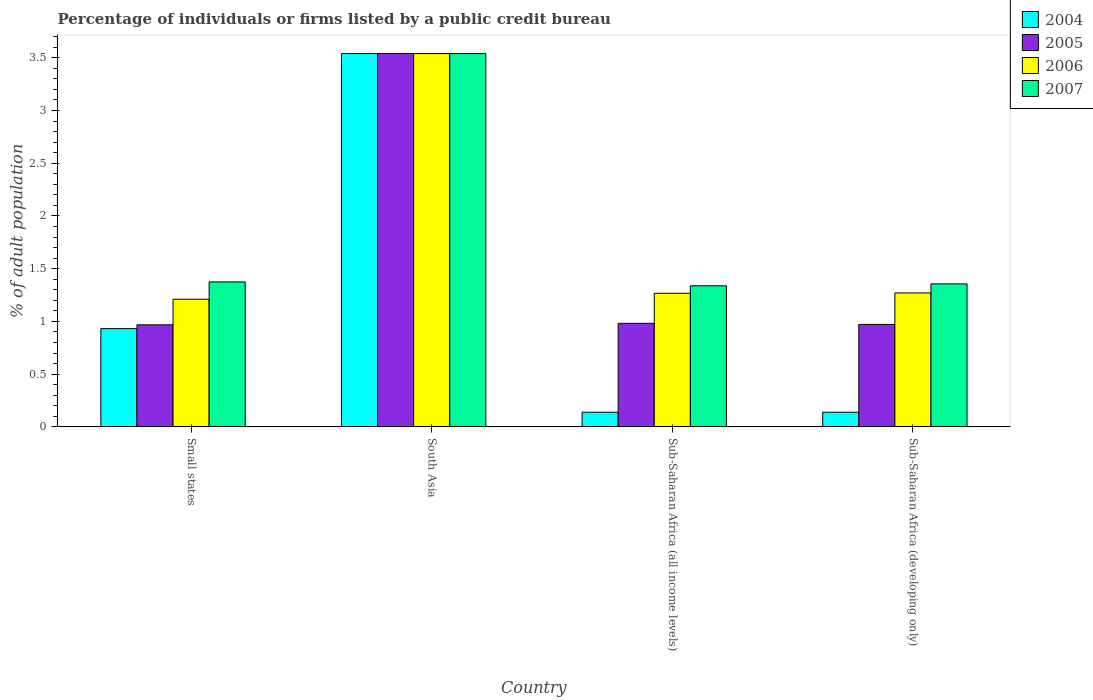How many different coloured bars are there?
Offer a very short reply. 4. How many groups of bars are there?
Provide a short and direct response. 4. Are the number of bars per tick equal to the number of legend labels?
Provide a succinct answer. Yes. How many bars are there on the 3rd tick from the left?
Provide a succinct answer. 4. What is the label of the 3rd group of bars from the left?
Provide a succinct answer. Sub-Saharan Africa (all income levels). What is the percentage of population listed by a public credit bureau in 2006 in Sub-Saharan Africa (developing only)?
Give a very brief answer. 1.27. Across all countries, what is the maximum percentage of population listed by a public credit bureau in 2005?
Your answer should be very brief. 3.54. Across all countries, what is the minimum percentage of population listed by a public credit bureau in 2004?
Ensure brevity in your answer.  0.14. In which country was the percentage of population listed by a public credit bureau in 2006 maximum?
Keep it short and to the point. South Asia. In which country was the percentage of population listed by a public credit bureau in 2006 minimum?
Offer a very short reply. Small states. What is the total percentage of population listed by a public credit bureau in 2006 in the graph?
Make the answer very short. 7.29. What is the difference between the percentage of population listed by a public credit bureau in 2005 in South Asia and that in Sub-Saharan Africa (developing only)?
Provide a succinct answer. 2.57. What is the difference between the percentage of population listed by a public credit bureau in 2006 in Small states and the percentage of population listed by a public credit bureau in 2007 in South Asia?
Keep it short and to the point. -2.33. What is the average percentage of population listed by a public credit bureau in 2005 per country?
Provide a succinct answer. 1.62. What is the difference between the percentage of population listed by a public credit bureau of/in 2004 and percentage of population listed by a public credit bureau of/in 2005 in Small states?
Give a very brief answer. -0.04. In how many countries, is the percentage of population listed by a public credit bureau in 2004 greater than 0.1 %?
Provide a succinct answer. 4. What is the ratio of the percentage of population listed by a public credit bureau in 2004 in Sub-Saharan Africa (all income levels) to that in Sub-Saharan Africa (developing only)?
Offer a very short reply. 1. Is the percentage of population listed by a public credit bureau in 2004 in Sub-Saharan Africa (all income levels) less than that in Sub-Saharan Africa (developing only)?
Provide a short and direct response. No. What is the difference between the highest and the second highest percentage of population listed by a public credit bureau in 2006?
Ensure brevity in your answer.  -2.27. What is the difference between the highest and the lowest percentage of population listed by a public credit bureau in 2005?
Give a very brief answer. 2.57. In how many countries, is the percentage of population listed by a public credit bureau in 2004 greater than the average percentage of population listed by a public credit bureau in 2004 taken over all countries?
Provide a short and direct response. 1. Is the sum of the percentage of population listed by a public credit bureau in 2005 in Small states and South Asia greater than the maximum percentage of population listed by a public credit bureau in 2006 across all countries?
Keep it short and to the point. Yes. Is it the case that in every country, the sum of the percentage of population listed by a public credit bureau in 2004 and percentage of population listed by a public credit bureau in 2006 is greater than the percentage of population listed by a public credit bureau in 2007?
Ensure brevity in your answer.  Yes. How many bars are there?
Provide a short and direct response. 16. What is the difference between two consecutive major ticks on the Y-axis?
Provide a short and direct response. 0.5. Are the values on the major ticks of Y-axis written in scientific E-notation?
Ensure brevity in your answer.  No. Does the graph contain any zero values?
Your answer should be very brief. No. How are the legend labels stacked?
Provide a succinct answer. Vertical. What is the title of the graph?
Offer a terse response. Percentage of individuals or firms listed by a public credit bureau. What is the label or title of the Y-axis?
Offer a very short reply. % of adult population. What is the % of adult population of 2004 in Small states?
Make the answer very short. 0.93. What is the % of adult population in 2005 in Small states?
Make the answer very short. 0.97. What is the % of adult population in 2006 in Small states?
Offer a terse response. 1.21. What is the % of adult population of 2007 in Small states?
Give a very brief answer. 1.37. What is the % of adult population of 2004 in South Asia?
Your response must be concise. 3.54. What is the % of adult population of 2005 in South Asia?
Provide a succinct answer. 3.54. What is the % of adult population of 2006 in South Asia?
Give a very brief answer. 3.54. What is the % of adult population of 2007 in South Asia?
Offer a very short reply. 3.54. What is the % of adult population in 2004 in Sub-Saharan Africa (all income levels)?
Give a very brief answer. 0.14. What is the % of adult population of 2005 in Sub-Saharan Africa (all income levels)?
Ensure brevity in your answer.  0.98. What is the % of adult population in 2006 in Sub-Saharan Africa (all income levels)?
Ensure brevity in your answer.  1.27. What is the % of adult population in 2007 in Sub-Saharan Africa (all income levels)?
Provide a short and direct response. 1.34. What is the % of adult population in 2004 in Sub-Saharan Africa (developing only)?
Provide a short and direct response. 0.14. What is the % of adult population in 2005 in Sub-Saharan Africa (developing only)?
Ensure brevity in your answer.  0.97. What is the % of adult population of 2006 in Sub-Saharan Africa (developing only)?
Keep it short and to the point. 1.27. What is the % of adult population in 2007 in Sub-Saharan Africa (developing only)?
Offer a terse response. 1.36. Across all countries, what is the maximum % of adult population in 2004?
Your answer should be compact. 3.54. Across all countries, what is the maximum % of adult population in 2005?
Ensure brevity in your answer.  3.54. Across all countries, what is the maximum % of adult population in 2006?
Make the answer very short. 3.54. Across all countries, what is the maximum % of adult population of 2007?
Give a very brief answer. 3.54. Across all countries, what is the minimum % of adult population in 2004?
Provide a short and direct response. 0.14. Across all countries, what is the minimum % of adult population in 2005?
Offer a terse response. 0.97. Across all countries, what is the minimum % of adult population in 2006?
Provide a short and direct response. 1.21. Across all countries, what is the minimum % of adult population of 2007?
Provide a short and direct response. 1.34. What is the total % of adult population in 2004 in the graph?
Offer a terse response. 4.75. What is the total % of adult population in 2005 in the graph?
Your response must be concise. 6.46. What is the total % of adult population of 2006 in the graph?
Offer a very short reply. 7.29. What is the total % of adult population of 2007 in the graph?
Offer a terse response. 7.61. What is the difference between the % of adult population of 2004 in Small states and that in South Asia?
Your response must be concise. -2.61. What is the difference between the % of adult population of 2005 in Small states and that in South Asia?
Offer a terse response. -2.57. What is the difference between the % of adult population in 2006 in Small states and that in South Asia?
Provide a short and direct response. -2.33. What is the difference between the % of adult population of 2007 in Small states and that in South Asia?
Offer a very short reply. -2.17. What is the difference between the % of adult population in 2004 in Small states and that in Sub-Saharan Africa (all income levels)?
Ensure brevity in your answer.  0.79. What is the difference between the % of adult population of 2005 in Small states and that in Sub-Saharan Africa (all income levels)?
Your answer should be compact. -0.01. What is the difference between the % of adult population in 2006 in Small states and that in Sub-Saharan Africa (all income levels)?
Your answer should be compact. -0.06. What is the difference between the % of adult population in 2007 in Small states and that in Sub-Saharan Africa (all income levels)?
Offer a very short reply. 0.04. What is the difference between the % of adult population in 2004 in Small states and that in Sub-Saharan Africa (developing only)?
Offer a very short reply. 0.79. What is the difference between the % of adult population of 2005 in Small states and that in Sub-Saharan Africa (developing only)?
Your answer should be very brief. -0. What is the difference between the % of adult population of 2006 in Small states and that in Sub-Saharan Africa (developing only)?
Provide a succinct answer. -0.06. What is the difference between the % of adult population of 2007 in Small states and that in Sub-Saharan Africa (developing only)?
Provide a succinct answer. 0.02. What is the difference between the % of adult population in 2004 in South Asia and that in Sub-Saharan Africa (all income levels)?
Ensure brevity in your answer.  3.4. What is the difference between the % of adult population of 2005 in South Asia and that in Sub-Saharan Africa (all income levels)?
Your answer should be compact. 2.56. What is the difference between the % of adult population in 2006 in South Asia and that in Sub-Saharan Africa (all income levels)?
Offer a very short reply. 2.27. What is the difference between the % of adult population of 2007 in South Asia and that in Sub-Saharan Africa (all income levels)?
Your answer should be very brief. 2.2. What is the difference between the % of adult population of 2004 in South Asia and that in Sub-Saharan Africa (developing only)?
Your answer should be compact. 3.4. What is the difference between the % of adult population of 2005 in South Asia and that in Sub-Saharan Africa (developing only)?
Your answer should be compact. 2.57. What is the difference between the % of adult population of 2006 in South Asia and that in Sub-Saharan Africa (developing only)?
Provide a succinct answer. 2.27. What is the difference between the % of adult population of 2007 in South Asia and that in Sub-Saharan Africa (developing only)?
Keep it short and to the point. 2.18. What is the difference between the % of adult population of 2005 in Sub-Saharan Africa (all income levels) and that in Sub-Saharan Africa (developing only)?
Offer a terse response. 0.01. What is the difference between the % of adult population of 2006 in Sub-Saharan Africa (all income levels) and that in Sub-Saharan Africa (developing only)?
Your answer should be very brief. -0. What is the difference between the % of adult population in 2007 in Sub-Saharan Africa (all income levels) and that in Sub-Saharan Africa (developing only)?
Your answer should be compact. -0.02. What is the difference between the % of adult population of 2004 in Small states and the % of adult population of 2005 in South Asia?
Your answer should be compact. -2.61. What is the difference between the % of adult population in 2004 in Small states and the % of adult population in 2006 in South Asia?
Keep it short and to the point. -2.61. What is the difference between the % of adult population in 2004 in Small states and the % of adult population in 2007 in South Asia?
Offer a very short reply. -2.61. What is the difference between the % of adult population in 2005 in Small states and the % of adult population in 2006 in South Asia?
Offer a terse response. -2.57. What is the difference between the % of adult population of 2005 in Small states and the % of adult population of 2007 in South Asia?
Give a very brief answer. -2.57. What is the difference between the % of adult population of 2006 in Small states and the % of adult population of 2007 in South Asia?
Offer a terse response. -2.33. What is the difference between the % of adult population in 2004 in Small states and the % of adult population in 2005 in Sub-Saharan Africa (all income levels)?
Offer a very short reply. -0.05. What is the difference between the % of adult population of 2004 in Small states and the % of adult population of 2006 in Sub-Saharan Africa (all income levels)?
Make the answer very short. -0.34. What is the difference between the % of adult population in 2004 in Small states and the % of adult population in 2007 in Sub-Saharan Africa (all income levels)?
Your answer should be compact. -0.41. What is the difference between the % of adult population of 2005 in Small states and the % of adult population of 2006 in Sub-Saharan Africa (all income levels)?
Your response must be concise. -0.3. What is the difference between the % of adult population in 2005 in Small states and the % of adult population in 2007 in Sub-Saharan Africa (all income levels)?
Make the answer very short. -0.37. What is the difference between the % of adult population in 2006 in Small states and the % of adult population in 2007 in Sub-Saharan Africa (all income levels)?
Provide a succinct answer. -0.13. What is the difference between the % of adult population of 2004 in Small states and the % of adult population of 2005 in Sub-Saharan Africa (developing only)?
Offer a terse response. -0.04. What is the difference between the % of adult population in 2004 in Small states and the % of adult population in 2006 in Sub-Saharan Africa (developing only)?
Your response must be concise. -0.34. What is the difference between the % of adult population in 2004 in Small states and the % of adult population in 2007 in Sub-Saharan Africa (developing only)?
Give a very brief answer. -0.42. What is the difference between the % of adult population of 2005 in Small states and the % of adult population of 2006 in Sub-Saharan Africa (developing only)?
Keep it short and to the point. -0.3. What is the difference between the % of adult population of 2005 in Small states and the % of adult population of 2007 in Sub-Saharan Africa (developing only)?
Your response must be concise. -0.39. What is the difference between the % of adult population of 2006 in Small states and the % of adult population of 2007 in Sub-Saharan Africa (developing only)?
Give a very brief answer. -0.15. What is the difference between the % of adult population in 2004 in South Asia and the % of adult population in 2005 in Sub-Saharan Africa (all income levels)?
Provide a short and direct response. 2.56. What is the difference between the % of adult population in 2004 in South Asia and the % of adult population in 2006 in Sub-Saharan Africa (all income levels)?
Your response must be concise. 2.27. What is the difference between the % of adult population in 2004 in South Asia and the % of adult population in 2007 in Sub-Saharan Africa (all income levels)?
Offer a terse response. 2.2. What is the difference between the % of adult population of 2005 in South Asia and the % of adult population of 2006 in Sub-Saharan Africa (all income levels)?
Make the answer very short. 2.27. What is the difference between the % of adult population of 2005 in South Asia and the % of adult population of 2007 in Sub-Saharan Africa (all income levels)?
Keep it short and to the point. 2.2. What is the difference between the % of adult population in 2006 in South Asia and the % of adult population in 2007 in Sub-Saharan Africa (all income levels)?
Provide a short and direct response. 2.2. What is the difference between the % of adult population in 2004 in South Asia and the % of adult population in 2005 in Sub-Saharan Africa (developing only)?
Provide a short and direct response. 2.57. What is the difference between the % of adult population in 2004 in South Asia and the % of adult population in 2006 in Sub-Saharan Africa (developing only)?
Your answer should be very brief. 2.27. What is the difference between the % of adult population in 2004 in South Asia and the % of adult population in 2007 in Sub-Saharan Africa (developing only)?
Your response must be concise. 2.18. What is the difference between the % of adult population in 2005 in South Asia and the % of adult population in 2006 in Sub-Saharan Africa (developing only)?
Offer a very short reply. 2.27. What is the difference between the % of adult population of 2005 in South Asia and the % of adult population of 2007 in Sub-Saharan Africa (developing only)?
Your answer should be compact. 2.18. What is the difference between the % of adult population in 2006 in South Asia and the % of adult population in 2007 in Sub-Saharan Africa (developing only)?
Your answer should be very brief. 2.18. What is the difference between the % of adult population of 2004 in Sub-Saharan Africa (all income levels) and the % of adult population of 2005 in Sub-Saharan Africa (developing only)?
Make the answer very short. -0.83. What is the difference between the % of adult population of 2004 in Sub-Saharan Africa (all income levels) and the % of adult population of 2006 in Sub-Saharan Africa (developing only)?
Keep it short and to the point. -1.13. What is the difference between the % of adult population in 2004 in Sub-Saharan Africa (all income levels) and the % of adult population in 2007 in Sub-Saharan Africa (developing only)?
Your response must be concise. -1.22. What is the difference between the % of adult population of 2005 in Sub-Saharan Africa (all income levels) and the % of adult population of 2006 in Sub-Saharan Africa (developing only)?
Keep it short and to the point. -0.29. What is the difference between the % of adult population of 2005 in Sub-Saharan Africa (all income levels) and the % of adult population of 2007 in Sub-Saharan Africa (developing only)?
Give a very brief answer. -0.37. What is the difference between the % of adult population of 2006 in Sub-Saharan Africa (all income levels) and the % of adult population of 2007 in Sub-Saharan Africa (developing only)?
Ensure brevity in your answer.  -0.09. What is the average % of adult population of 2004 per country?
Your answer should be very brief. 1.19. What is the average % of adult population of 2005 per country?
Give a very brief answer. 1.62. What is the average % of adult population in 2006 per country?
Provide a succinct answer. 1.82. What is the average % of adult population of 2007 per country?
Provide a short and direct response. 1.9. What is the difference between the % of adult population of 2004 and % of adult population of 2005 in Small states?
Offer a very short reply. -0.04. What is the difference between the % of adult population in 2004 and % of adult population in 2006 in Small states?
Provide a short and direct response. -0.28. What is the difference between the % of adult population of 2004 and % of adult population of 2007 in Small states?
Give a very brief answer. -0.44. What is the difference between the % of adult population of 2005 and % of adult population of 2006 in Small states?
Your answer should be compact. -0.24. What is the difference between the % of adult population of 2005 and % of adult population of 2007 in Small states?
Give a very brief answer. -0.41. What is the difference between the % of adult population in 2006 and % of adult population in 2007 in Small states?
Your response must be concise. -0.16. What is the difference between the % of adult population in 2004 and % of adult population in 2006 in South Asia?
Ensure brevity in your answer.  0. What is the difference between the % of adult population in 2005 and % of adult population in 2007 in South Asia?
Give a very brief answer. 0. What is the difference between the % of adult population in 2004 and % of adult population in 2005 in Sub-Saharan Africa (all income levels)?
Your response must be concise. -0.84. What is the difference between the % of adult population of 2004 and % of adult population of 2006 in Sub-Saharan Africa (all income levels)?
Ensure brevity in your answer.  -1.13. What is the difference between the % of adult population of 2004 and % of adult population of 2007 in Sub-Saharan Africa (all income levels)?
Provide a short and direct response. -1.2. What is the difference between the % of adult population of 2005 and % of adult population of 2006 in Sub-Saharan Africa (all income levels)?
Your answer should be compact. -0.28. What is the difference between the % of adult population in 2005 and % of adult population in 2007 in Sub-Saharan Africa (all income levels)?
Your answer should be very brief. -0.36. What is the difference between the % of adult population in 2006 and % of adult population in 2007 in Sub-Saharan Africa (all income levels)?
Offer a terse response. -0.07. What is the difference between the % of adult population in 2004 and % of adult population in 2005 in Sub-Saharan Africa (developing only)?
Your answer should be very brief. -0.83. What is the difference between the % of adult population in 2004 and % of adult population in 2006 in Sub-Saharan Africa (developing only)?
Provide a short and direct response. -1.13. What is the difference between the % of adult population in 2004 and % of adult population in 2007 in Sub-Saharan Africa (developing only)?
Ensure brevity in your answer.  -1.22. What is the difference between the % of adult population in 2005 and % of adult population in 2006 in Sub-Saharan Africa (developing only)?
Your response must be concise. -0.3. What is the difference between the % of adult population of 2005 and % of adult population of 2007 in Sub-Saharan Africa (developing only)?
Keep it short and to the point. -0.38. What is the difference between the % of adult population of 2006 and % of adult population of 2007 in Sub-Saharan Africa (developing only)?
Ensure brevity in your answer.  -0.09. What is the ratio of the % of adult population of 2004 in Small states to that in South Asia?
Your answer should be very brief. 0.26. What is the ratio of the % of adult population in 2005 in Small states to that in South Asia?
Give a very brief answer. 0.27. What is the ratio of the % of adult population in 2006 in Small states to that in South Asia?
Your response must be concise. 0.34. What is the ratio of the % of adult population of 2007 in Small states to that in South Asia?
Your answer should be compact. 0.39. What is the ratio of the % of adult population in 2004 in Small states to that in Sub-Saharan Africa (all income levels)?
Ensure brevity in your answer.  6.71. What is the ratio of the % of adult population of 2005 in Small states to that in Sub-Saharan Africa (all income levels)?
Give a very brief answer. 0.99. What is the ratio of the % of adult population of 2006 in Small states to that in Sub-Saharan Africa (all income levels)?
Your response must be concise. 0.96. What is the ratio of the % of adult population in 2007 in Small states to that in Sub-Saharan Africa (all income levels)?
Provide a short and direct response. 1.03. What is the ratio of the % of adult population of 2004 in Small states to that in Sub-Saharan Africa (developing only)?
Provide a short and direct response. 6.71. What is the ratio of the % of adult population of 2005 in Small states to that in Sub-Saharan Africa (developing only)?
Your answer should be compact. 1. What is the ratio of the % of adult population in 2006 in Small states to that in Sub-Saharan Africa (developing only)?
Your answer should be compact. 0.95. What is the ratio of the % of adult population in 2007 in Small states to that in Sub-Saharan Africa (developing only)?
Keep it short and to the point. 1.01. What is the ratio of the % of adult population in 2004 in South Asia to that in Sub-Saharan Africa (all income levels)?
Your answer should be compact. 25.49. What is the ratio of the % of adult population in 2005 in South Asia to that in Sub-Saharan Africa (all income levels)?
Provide a succinct answer. 3.61. What is the ratio of the % of adult population of 2006 in South Asia to that in Sub-Saharan Africa (all income levels)?
Make the answer very short. 2.79. What is the ratio of the % of adult population in 2007 in South Asia to that in Sub-Saharan Africa (all income levels)?
Keep it short and to the point. 2.65. What is the ratio of the % of adult population in 2004 in South Asia to that in Sub-Saharan Africa (developing only)?
Your answer should be compact. 25.49. What is the ratio of the % of adult population of 2005 in South Asia to that in Sub-Saharan Africa (developing only)?
Your answer should be compact. 3.64. What is the ratio of the % of adult population in 2006 in South Asia to that in Sub-Saharan Africa (developing only)?
Keep it short and to the point. 2.79. What is the ratio of the % of adult population of 2007 in South Asia to that in Sub-Saharan Africa (developing only)?
Offer a very short reply. 2.61. What is the ratio of the % of adult population of 2004 in Sub-Saharan Africa (all income levels) to that in Sub-Saharan Africa (developing only)?
Offer a very short reply. 1. What is the ratio of the % of adult population of 2005 in Sub-Saharan Africa (all income levels) to that in Sub-Saharan Africa (developing only)?
Offer a very short reply. 1.01. What is the ratio of the % of adult population in 2006 in Sub-Saharan Africa (all income levels) to that in Sub-Saharan Africa (developing only)?
Provide a short and direct response. 1. What is the ratio of the % of adult population in 2007 in Sub-Saharan Africa (all income levels) to that in Sub-Saharan Africa (developing only)?
Make the answer very short. 0.99. What is the difference between the highest and the second highest % of adult population in 2004?
Make the answer very short. 2.61. What is the difference between the highest and the second highest % of adult population of 2005?
Provide a succinct answer. 2.56. What is the difference between the highest and the second highest % of adult population of 2006?
Offer a terse response. 2.27. What is the difference between the highest and the second highest % of adult population in 2007?
Your answer should be compact. 2.17. What is the difference between the highest and the lowest % of adult population in 2004?
Your response must be concise. 3.4. What is the difference between the highest and the lowest % of adult population in 2005?
Give a very brief answer. 2.57. What is the difference between the highest and the lowest % of adult population in 2006?
Provide a succinct answer. 2.33. What is the difference between the highest and the lowest % of adult population of 2007?
Provide a short and direct response. 2.2. 